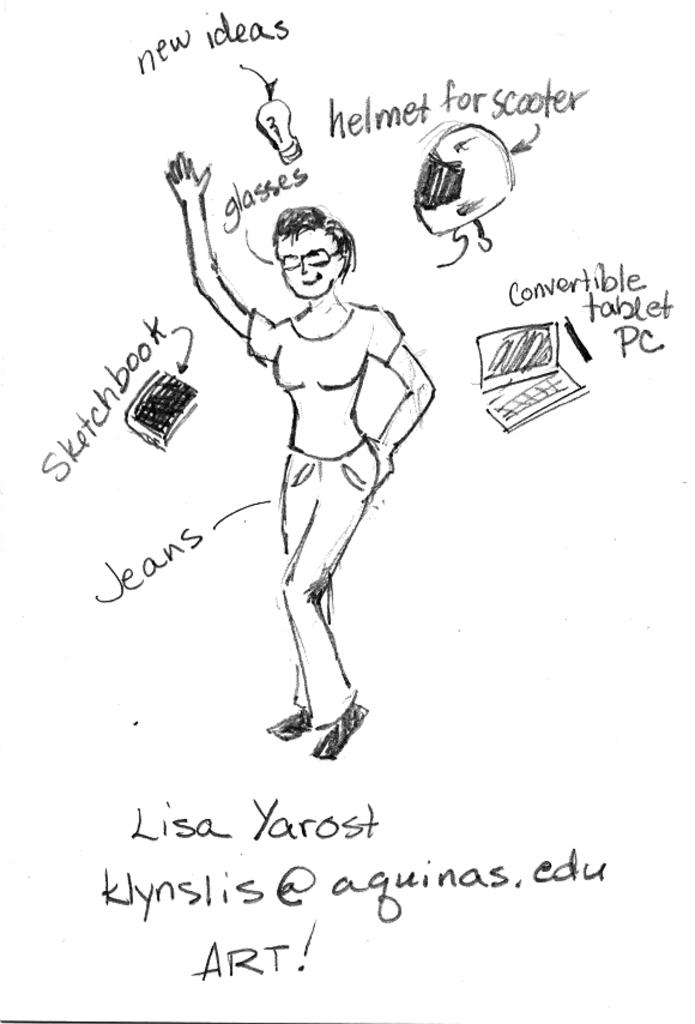What medium is used to create the image? The image appears to be a pencil art on paper. What is the main subject of the art? There is a person standing in the art. What protective gear is the person wearing? A helmet is visible in the art. What objects are related to light and knowledge in the art? A bulb and a book are depicted in the art. What electronic device is shown in the art? A computer is shown in the art. Are there any words or letters in the art? Yes, there are letters on the paper in the art. How many dishes are served during the feast in the image? There is no feast present in the image; it is a pencil art featuring a person, a helmet, a bulb, a book, a computer, and letters on paper. 